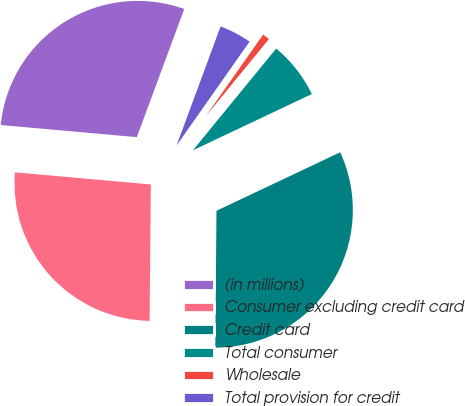Convert chart to OTSL. <chart><loc_0><loc_0><loc_500><loc_500><pie_chart><fcel>(in millions)<fcel>Consumer excluding credit card<fcel>Credit card<fcel>Total consumer<fcel>Wholesale<fcel>Total provision for credit<nl><fcel>29.22%<fcel>26.28%<fcel>32.17%<fcel>7.05%<fcel>1.17%<fcel>4.11%<nl></chart> 